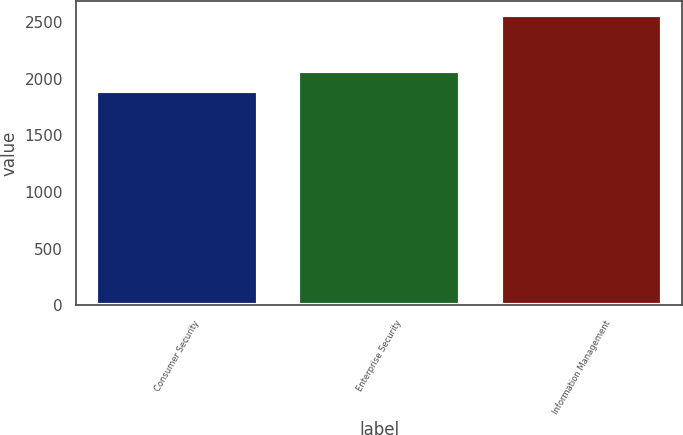Convert chart. <chart><loc_0><loc_0><loc_500><loc_500><bar_chart><fcel>Consumer Security<fcel>Enterprise Security<fcel>Information Management<nl><fcel>1887<fcel>2063<fcel>2558<nl></chart> 